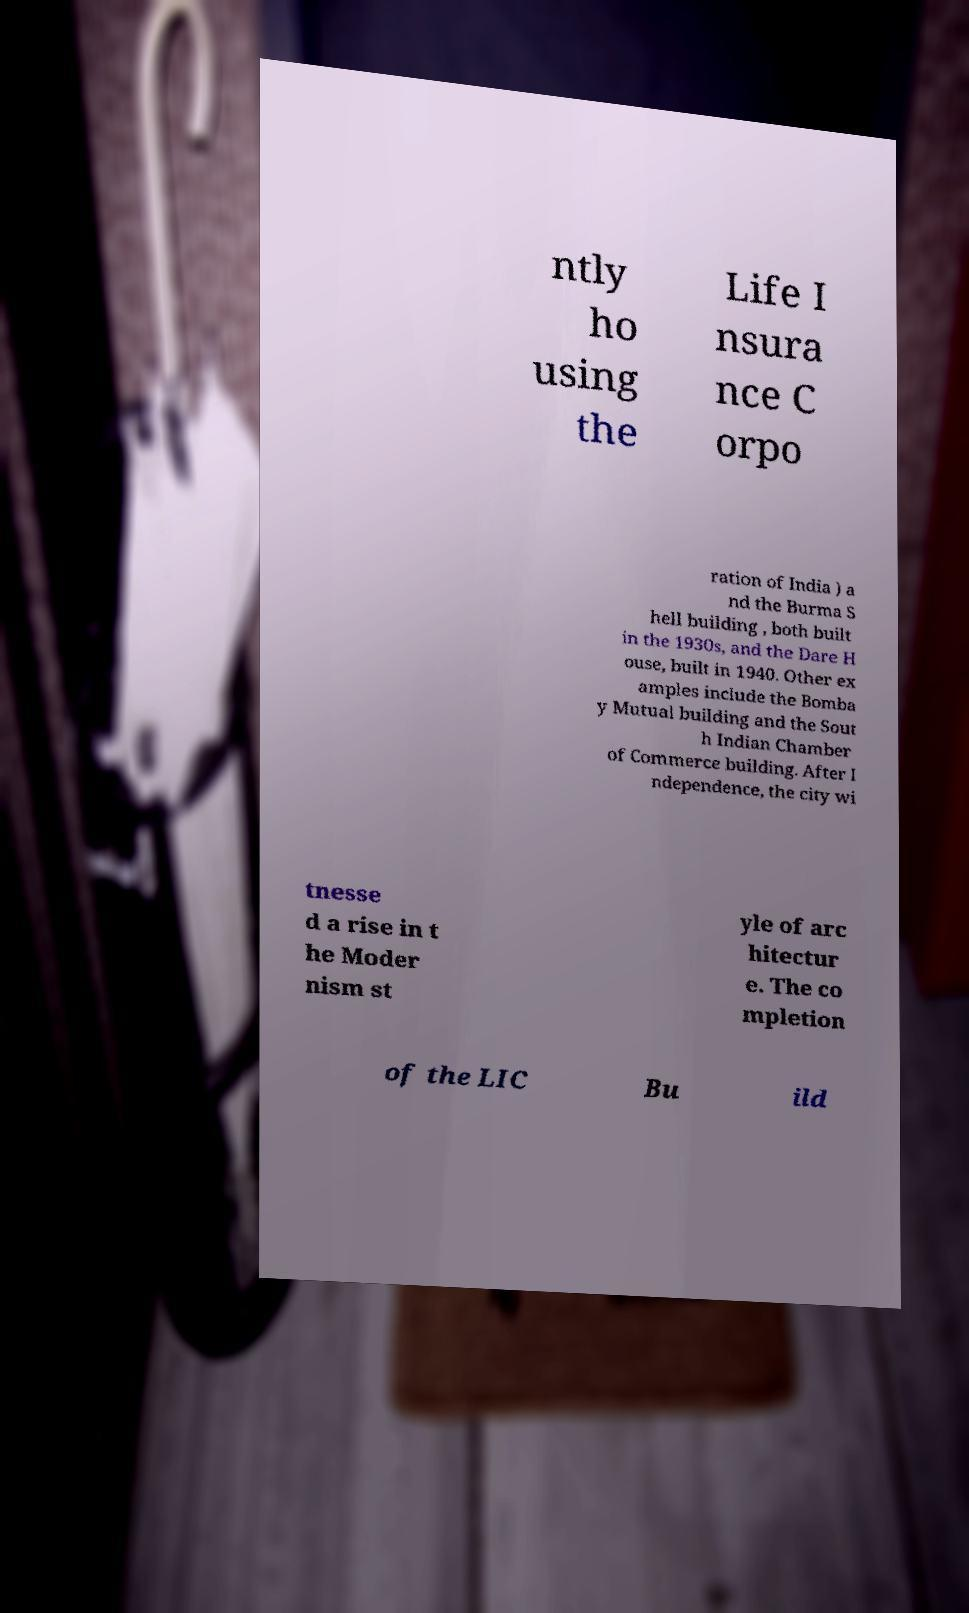What messages or text are displayed in this image? I need them in a readable, typed format. ntly ho using the Life I nsura nce C orpo ration of India ) a nd the Burma S hell building , both built in the 1930s, and the Dare H ouse, built in 1940. Other ex amples include the Bomba y Mutual building and the Sout h Indian Chamber of Commerce building. After I ndependence, the city wi tnesse d a rise in t he Moder nism st yle of arc hitectur e. The co mpletion of the LIC Bu ild 